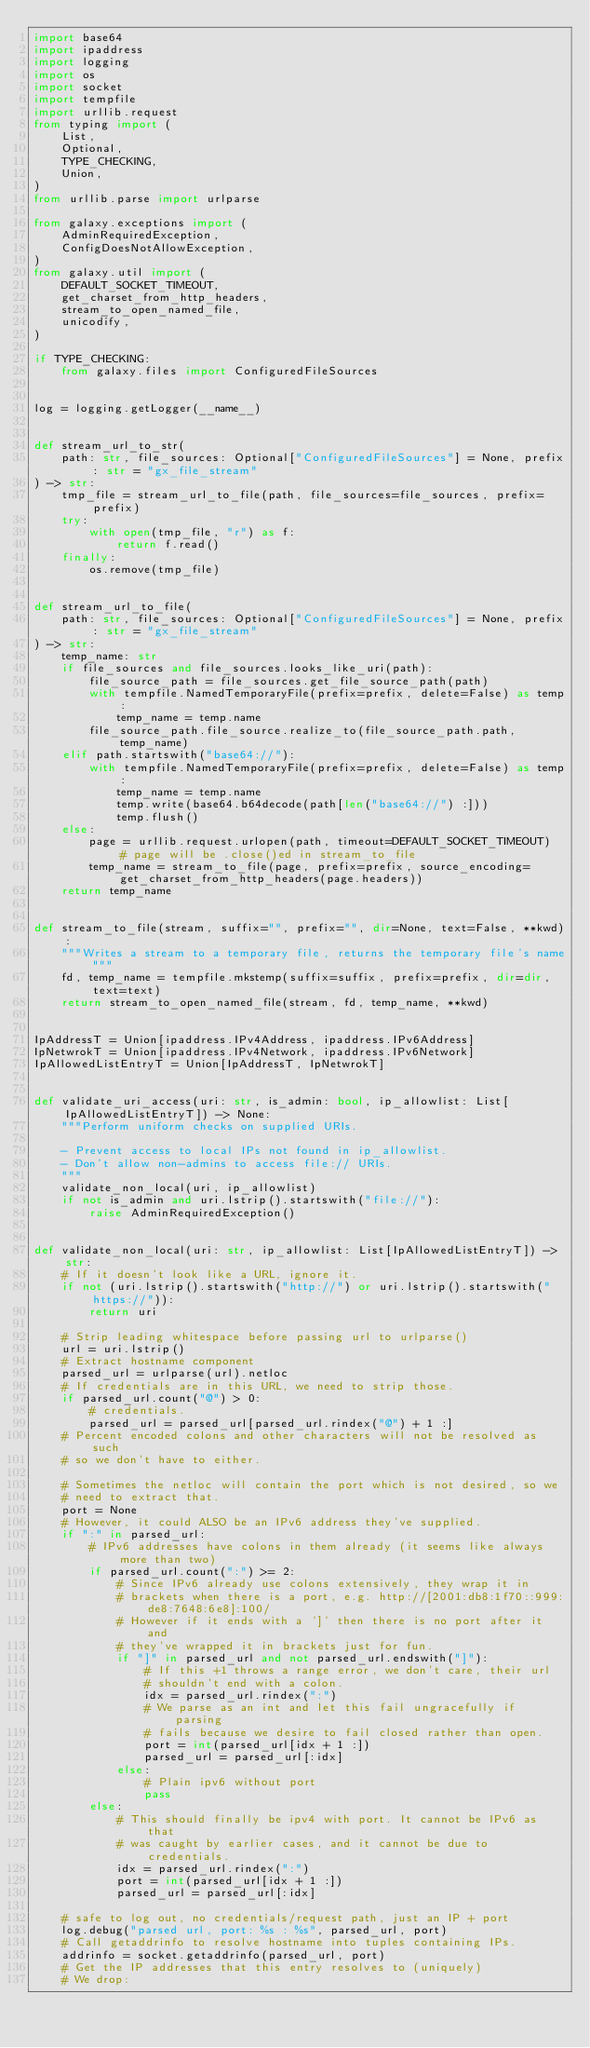Convert code to text. <code><loc_0><loc_0><loc_500><loc_500><_Python_>import base64
import ipaddress
import logging
import os
import socket
import tempfile
import urllib.request
from typing import (
    List,
    Optional,
    TYPE_CHECKING,
    Union,
)
from urllib.parse import urlparse

from galaxy.exceptions import (
    AdminRequiredException,
    ConfigDoesNotAllowException,
)
from galaxy.util import (
    DEFAULT_SOCKET_TIMEOUT,
    get_charset_from_http_headers,
    stream_to_open_named_file,
    unicodify,
)

if TYPE_CHECKING:
    from galaxy.files import ConfiguredFileSources


log = logging.getLogger(__name__)


def stream_url_to_str(
    path: str, file_sources: Optional["ConfiguredFileSources"] = None, prefix: str = "gx_file_stream"
) -> str:
    tmp_file = stream_url_to_file(path, file_sources=file_sources, prefix=prefix)
    try:
        with open(tmp_file, "r") as f:
            return f.read()
    finally:
        os.remove(tmp_file)


def stream_url_to_file(
    path: str, file_sources: Optional["ConfiguredFileSources"] = None, prefix: str = "gx_file_stream"
) -> str:
    temp_name: str
    if file_sources and file_sources.looks_like_uri(path):
        file_source_path = file_sources.get_file_source_path(path)
        with tempfile.NamedTemporaryFile(prefix=prefix, delete=False) as temp:
            temp_name = temp.name
        file_source_path.file_source.realize_to(file_source_path.path, temp_name)
    elif path.startswith("base64://"):
        with tempfile.NamedTemporaryFile(prefix=prefix, delete=False) as temp:
            temp_name = temp.name
            temp.write(base64.b64decode(path[len("base64://") :]))
            temp.flush()
    else:
        page = urllib.request.urlopen(path, timeout=DEFAULT_SOCKET_TIMEOUT)  # page will be .close()ed in stream_to_file
        temp_name = stream_to_file(page, prefix=prefix, source_encoding=get_charset_from_http_headers(page.headers))
    return temp_name


def stream_to_file(stream, suffix="", prefix="", dir=None, text=False, **kwd):
    """Writes a stream to a temporary file, returns the temporary file's name"""
    fd, temp_name = tempfile.mkstemp(suffix=suffix, prefix=prefix, dir=dir, text=text)
    return stream_to_open_named_file(stream, fd, temp_name, **kwd)


IpAddressT = Union[ipaddress.IPv4Address, ipaddress.IPv6Address]
IpNetwrokT = Union[ipaddress.IPv4Network, ipaddress.IPv6Network]
IpAllowedListEntryT = Union[IpAddressT, IpNetwrokT]


def validate_uri_access(uri: str, is_admin: bool, ip_allowlist: List[IpAllowedListEntryT]) -> None:
    """Perform uniform checks on supplied URIs.

    - Prevent access to local IPs not found in ip_allowlist.
    - Don't allow non-admins to access file:// URIs.
    """
    validate_non_local(uri, ip_allowlist)
    if not is_admin and uri.lstrip().startswith("file://"):
        raise AdminRequiredException()


def validate_non_local(uri: str, ip_allowlist: List[IpAllowedListEntryT]) -> str:
    # If it doesn't look like a URL, ignore it.
    if not (uri.lstrip().startswith("http://") or uri.lstrip().startswith("https://")):
        return uri

    # Strip leading whitespace before passing url to urlparse()
    url = uri.lstrip()
    # Extract hostname component
    parsed_url = urlparse(url).netloc
    # If credentials are in this URL, we need to strip those.
    if parsed_url.count("@") > 0:
        # credentials.
        parsed_url = parsed_url[parsed_url.rindex("@") + 1 :]
    # Percent encoded colons and other characters will not be resolved as such
    # so we don't have to either.

    # Sometimes the netloc will contain the port which is not desired, so we
    # need to extract that.
    port = None
    # However, it could ALSO be an IPv6 address they've supplied.
    if ":" in parsed_url:
        # IPv6 addresses have colons in them already (it seems like always more than two)
        if parsed_url.count(":") >= 2:
            # Since IPv6 already use colons extensively, they wrap it in
            # brackets when there is a port, e.g. http://[2001:db8:1f70::999:de8:7648:6e8]:100/
            # However if it ends with a ']' then there is no port after it and
            # they've wrapped it in brackets just for fun.
            if "]" in parsed_url and not parsed_url.endswith("]"):
                # If this +1 throws a range error, we don't care, their url
                # shouldn't end with a colon.
                idx = parsed_url.rindex(":")
                # We parse as an int and let this fail ungracefully if parsing
                # fails because we desire to fail closed rather than open.
                port = int(parsed_url[idx + 1 :])
                parsed_url = parsed_url[:idx]
            else:
                # Plain ipv6 without port
                pass
        else:
            # This should finally be ipv4 with port. It cannot be IPv6 as that
            # was caught by earlier cases, and it cannot be due to credentials.
            idx = parsed_url.rindex(":")
            port = int(parsed_url[idx + 1 :])
            parsed_url = parsed_url[:idx]

    # safe to log out, no credentials/request path, just an IP + port
    log.debug("parsed url, port: %s : %s", parsed_url, port)
    # Call getaddrinfo to resolve hostname into tuples containing IPs.
    addrinfo = socket.getaddrinfo(parsed_url, port)
    # Get the IP addresses that this entry resolves to (uniquely)
    # We drop:</code> 